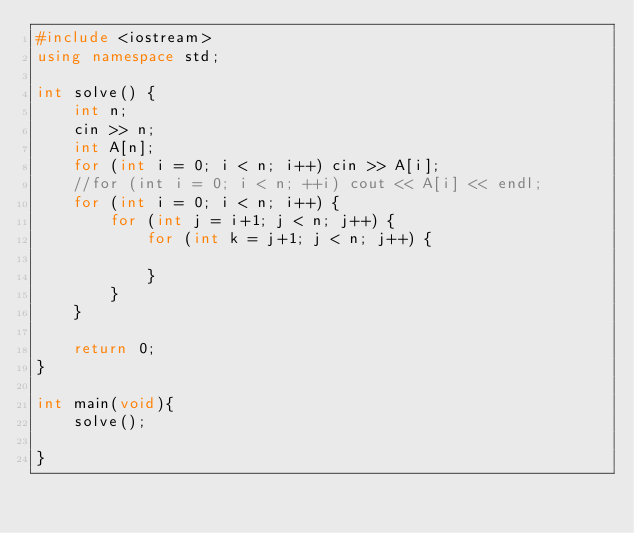<code> <loc_0><loc_0><loc_500><loc_500><_C++_>#include <iostream>
using namespace std;

int solve() {
    int n;
    cin >> n;
    int A[n]; 
    for (int i = 0; i < n; i++) cin >> A[i];
    //for (int i = 0; i < n; ++i) cout << A[i] << endl;
    for (int i = 0; i < n; i++) {  
        for (int j = i+1; j < n; j++) {  
            for (int k = j+1; j < n; j++) {  
    
            }
        }
    }
    
    return 0;
}

int main(void){
    solve();

}</code> 